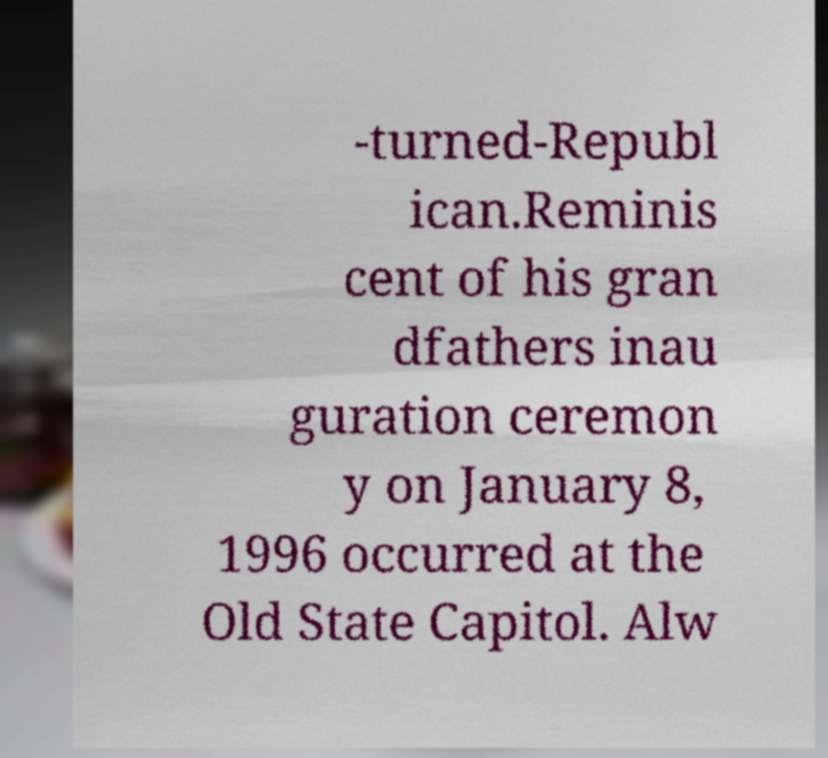Can you accurately transcribe the text from the provided image for me? -turned-Republ ican.Reminis cent of his gran dfathers inau guration ceremon y on January 8, 1996 occurred at the Old State Capitol. Alw 